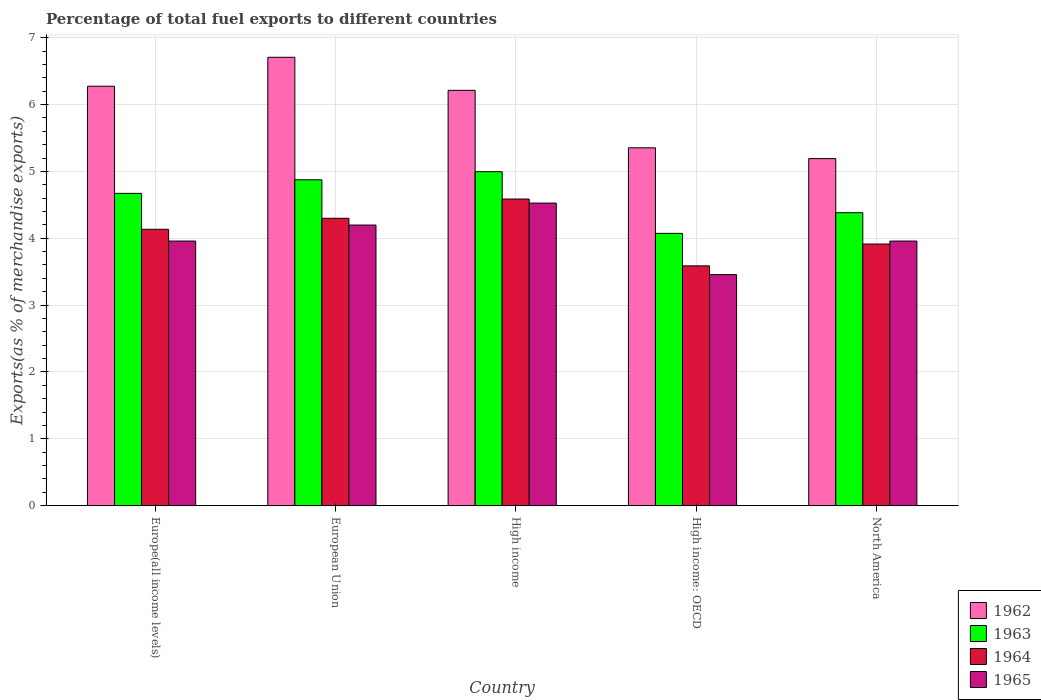Are the number of bars per tick equal to the number of legend labels?
Give a very brief answer. Yes. How many bars are there on the 2nd tick from the right?
Your response must be concise. 4. What is the label of the 1st group of bars from the left?
Your response must be concise. Europe(all income levels). What is the percentage of exports to different countries in 1962 in European Union?
Offer a terse response. 6.71. Across all countries, what is the maximum percentage of exports to different countries in 1964?
Give a very brief answer. 4.59. Across all countries, what is the minimum percentage of exports to different countries in 1965?
Offer a very short reply. 3.46. In which country was the percentage of exports to different countries in 1962 maximum?
Give a very brief answer. European Union. In which country was the percentage of exports to different countries in 1963 minimum?
Give a very brief answer. High income: OECD. What is the total percentage of exports to different countries in 1964 in the graph?
Provide a succinct answer. 20.52. What is the difference between the percentage of exports to different countries in 1963 in European Union and that in High income: OECD?
Ensure brevity in your answer.  0.8. What is the difference between the percentage of exports to different countries in 1964 in North America and the percentage of exports to different countries in 1963 in High income: OECD?
Offer a terse response. -0.16. What is the average percentage of exports to different countries in 1963 per country?
Ensure brevity in your answer.  4.6. What is the difference between the percentage of exports to different countries of/in 1963 and percentage of exports to different countries of/in 1962 in High income: OECD?
Make the answer very short. -1.28. What is the ratio of the percentage of exports to different countries in 1963 in Europe(all income levels) to that in North America?
Your response must be concise. 1.07. Is the percentage of exports to different countries in 1965 in European Union less than that in High income: OECD?
Keep it short and to the point. No. Is the difference between the percentage of exports to different countries in 1963 in European Union and High income greater than the difference between the percentage of exports to different countries in 1962 in European Union and High income?
Make the answer very short. No. What is the difference between the highest and the second highest percentage of exports to different countries in 1963?
Your answer should be very brief. -0.32. What is the difference between the highest and the lowest percentage of exports to different countries in 1964?
Provide a short and direct response. 1. In how many countries, is the percentage of exports to different countries in 1962 greater than the average percentage of exports to different countries in 1962 taken over all countries?
Give a very brief answer. 3. What does the 4th bar from the left in Europe(all income levels) represents?
Offer a very short reply. 1965. How many bars are there?
Your answer should be compact. 20. What is the difference between two consecutive major ticks on the Y-axis?
Your answer should be compact. 1. Are the values on the major ticks of Y-axis written in scientific E-notation?
Provide a succinct answer. No. Does the graph contain grids?
Give a very brief answer. Yes. How many legend labels are there?
Give a very brief answer. 4. How are the legend labels stacked?
Make the answer very short. Vertical. What is the title of the graph?
Offer a very short reply. Percentage of total fuel exports to different countries. What is the label or title of the Y-axis?
Offer a terse response. Exports(as % of merchandise exports). What is the Exports(as % of merchandise exports) of 1962 in Europe(all income levels)?
Your answer should be compact. 6.27. What is the Exports(as % of merchandise exports) of 1963 in Europe(all income levels)?
Keep it short and to the point. 4.67. What is the Exports(as % of merchandise exports) in 1964 in Europe(all income levels)?
Keep it short and to the point. 4.13. What is the Exports(as % of merchandise exports) in 1965 in Europe(all income levels)?
Provide a short and direct response. 3.96. What is the Exports(as % of merchandise exports) of 1962 in European Union?
Make the answer very short. 6.71. What is the Exports(as % of merchandise exports) in 1963 in European Union?
Provide a short and direct response. 4.87. What is the Exports(as % of merchandise exports) in 1964 in European Union?
Provide a succinct answer. 4.3. What is the Exports(as % of merchandise exports) of 1965 in European Union?
Provide a short and direct response. 4.2. What is the Exports(as % of merchandise exports) of 1962 in High income?
Your answer should be very brief. 6.21. What is the Exports(as % of merchandise exports) of 1963 in High income?
Your answer should be compact. 5. What is the Exports(as % of merchandise exports) in 1964 in High income?
Give a very brief answer. 4.59. What is the Exports(as % of merchandise exports) of 1965 in High income?
Provide a succinct answer. 4.53. What is the Exports(as % of merchandise exports) in 1962 in High income: OECD?
Provide a short and direct response. 5.35. What is the Exports(as % of merchandise exports) of 1963 in High income: OECD?
Offer a terse response. 4.07. What is the Exports(as % of merchandise exports) of 1964 in High income: OECD?
Your answer should be very brief. 3.59. What is the Exports(as % of merchandise exports) of 1965 in High income: OECD?
Offer a terse response. 3.46. What is the Exports(as % of merchandise exports) of 1962 in North America?
Offer a terse response. 5.19. What is the Exports(as % of merchandise exports) of 1963 in North America?
Give a very brief answer. 4.38. What is the Exports(as % of merchandise exports) in 1964 in North America?
Give a very brief answer. 3.91. What is the Exports(as % of merchandise exports) in 1965 in North America?
Give a very brief answer. 3.96. Across all countries, what is the maximum Exports(as % of merchandise exports) in 1962?
Your answer should be compact. 6.71. Across all countries, what is the maximum Exports(as % of merchandise exports) of 1963?
Keep it short and to the point. 5. Across all countries, what is the maximum Exports(as % of merchandise exports) in 1964?
Ensure brevity in your answer.  4.59. Across all countries, what is the maximum Exports(as % of merchandise exports) of 1965?
Your response must be concise. 4.53. Across all countries, what is the minimum Exports(as % of merchandise exports) in 1962?
Offer a very short reply. 5.19. Across all countries, what is the minimum Exports(as % of merchandise exports) of 1963?
Make the answer very short. 4.07. Across all countries, what is the minimum Exports(as % of merchandise exports) of 1964?
Offer a terse response. 3.59. Across all countries, what is the minimum Exports(as % of merchandise exports) in 1965?
Make the answer very short. 3.46. What is the total Exports(as % of merchandise exports) in 1962 in the graph?
Keep it short and to the point. 29.73. What is the total Exports(as % of merchandise exports) in 1963 in the graph?
Your answer should be compact. 23. What is the total Exports(as % of merchandise exports) in 1964 in the graph?
Give a very brief answer. 20.52. What is the total Exports(as % of merchandise exports) of 1965 in the graph?
Provide a short and direct response. 20.09. What is the difference between the Exports(as % of merchandise exports) in 1962 in Europe(all income levels) and that in European Union?
Provide a short and direct response. -0.43. What is the difference between the Exports(as % of merchandise exports) in 1963 in Europe(all income levels) and that in European Union?
Make the answer very short. -0.2. What is the difference between the Exports(as % of merchandise exports) in 1964 in Europe(all income levels) and that in European Union?
Ensure brevity in your answer.  -0.16. What is the difference between the Exports(as % of merchandise exports) of 1965 in Europe(all income levels) and that in European Union?
Provide a short and direct response. -0.24. What is the difference between the Exports(as % of merchandise exports) of 1962 in Europe(all income levels) and that in High income?
Provide a succinct answer. 0.06. What is the difference between the Exports(as % of merchandise exports) in 1963 in Europe(all income levels) and that in High income?
Make the answer very short. -0.32. What is the difference between the Exports(as % of merchandise exports) of 1964 in Europe(all income levels) and that in High income?
Your response must be concise. -0.45. What is the difference between the Exports(as % of merchandise exports) of 1965 in Europe(all income levels) and that in High income?
Offer a very short reply. -0.57. What is the difference between the Exports(as % of merchandise exports) of 1962 in Europe(all income levels) and that in High income: OECD?
Your answer should be very brief. 0.92. What is the difference between the Exports(as % of merchandise exports) in 1963 in Europe(all income levels) and that in High income: OECD?
Keep it short and to the point. 0.6. What is the difference between the Exports(as % of merchandise exports) in 1964 in Europe(all income levels) and that in High income: OECD?
Provide a succinct answer. 0.55. What is the difference between the Exports(as % of merchandise exports) of 1965 in Europe(all income levels) and that in High income: OECD?
Give a very brief answer. 0.5. What is the difference between the Exports(as % of merchandise exports) of 1962 in Europe(all income levels) and that in North America?
Your answer should be very brief. 1.08. What is the difference between the Exports(as % of merchandise exports) in 1963 in Europe(all income levels) and that in North America?
Provide a short and direct response. 0.29. What is the difference between the Exports(as % of merchandise exports) of 1964 in Europe(all income levels) and that in North America?
Give a very brief answer. 0.22. What is the difference between the Exports(as % of merchandise exports) in 1962 in European Union and that in High income?
Your response must be concise. 0.49. What is the difference between the Exports(as % of merchandise exports) in 1963 in European Union and that in High income?
Offer a very short reply. -0.12. What is the difference between the Exports(as % of merchandise exports) of 1964 in European Union and that in High income?
Give a very brief answer. -0.29. What is the difference between the Exports(as % of merchandise exports) of 1965 in European Union and that in High income?
Offer a very short reply. -0.33. What is the difference between the Exports(as % of merchandise exports) of 1962 in European Union and that in High income: OECD?
Offer a very short reply. 1.35. What is the difference between the Exports(as % of merchandise exports) in 1963 in European Union and that in High income: OECD?
Provide a succinct answer. 0.8. What is the difference between the Exports(as % of merchandise exports) of 1964 in European Union and that in High income: OECD?
Your answer should be compact. 0.71. What is the difference between the Exports(as % of merchandise exports) of 1965 in European Union and that in High income: OECD?
Offer a terse response. 0.74. What is the difference between the Exports(as % of merchandise exports) of 1962 in European Union and that in North America?
Your response must be concise. 1.52. What is the difference between the Exports(as % of merchandise exports) in 1963 in European Union and that in North America?
Provide a succinct answer. 0.49. What is the difference between the Exports(as % of merchandise exports) in 1964 in European Union and that in North America?
Provide a succinct answer. 0.39. What is the difference between the Exports(as % of merchandise exports) in 1965 in European Union and that in North America?
Your response must be concise. 0.24. What is the difference between the Exports(as % of merchandise exports) in 1962 in High income and that in High income: OECD?
Your response must be concise. 0.86. What is the difference between the Exports(as % of merchandise exports) in 1963 in High income and that in High income: OECD?
Ensure brevity in your answer.  0.92. What is the difference between the Exports(as % of merchandise exports) in 1964 in High income and that in High income: OECD?
Give a very brief answer. 1. What is the difference between the Exports(as % of merchandise exports) of 1965 in High income and that in High income: OECD?
Ensure brevity in your answer.  1.07. What is the difference between the Exports(as % of merchandise exports) in 1963 in High income and that in North America?
Keep it short and to the point. 0.61. What is the difference between the Exports(as % of merchandise exports) in 1964 in High income and that in North America?
Your answer should be very brief. 0.67. What is the difference between the Exports(as % of merchandise exports) in 1965 in High income and that in North America?
Offer a terse response. 0.57. What is the difference between the Exports(as % of merchandise exports) of 1962 in High income: OECD and that in North America?
Offer a terse response. 0.16. What is the difference between the Exports(as % of merchandise exports) of 1963 in High income: OECD and that in North America?
Keep it short and to the point. -0.31. What is the difference between the Exports(as % of merchandise exports) of 1964 in High income: OECD and that in North America?
Your response must be concise. -0.33. What is the difference between the Exports(as % of merchandise exports) in 1965 in High income: OECD and that in North America?
Your response must be concise. -0.5. What is the difference between the Exports(as % of merchandise exports) of 1962 in Europe(all income levels) and the Exports(as % of merchandise exports) of 1963 in European Union?
Make the answer very short. 1.4. What is the difference between the Exports(as % of merchandise exports) in 1962 in Europe(all income levels) and the Exports(as % of merchandise exports) in 1964 in European Union?
Your answer should be very brief. 1.97. What is the difference between the Exports(as % of merchandise exports) in 1962 in Europe(all income levels) and the Exports(as % of merchandise exports) in 1965 in European Union?
Your answer should be very brief. 2.08. What is the difference between the Exports(as % of merchandise exports) of 1963 in Europe(all income levels) and the Exports(as % of merchandise exports) of 1964 in European Union?
Provide a succinct answer. 0.37. What is the difference between the Exports(as % of merchandise exports) of 1963 in Europe(all income levels) and the Exports(as % of merchandise exports) of 1965 in European Union?
Provide a succinct answer. 0.47. What is the difference between the Exports(as % of merchandise exports) in 1964 in Europe(all income levels) and the Exports(as % of merchandise exports) in 1965 in European Union?
Offer a very short reply. -0.06. What is the difference between the Exports(as % of merchandise exports) in 1962 in Europe(all income levels) and the Exports(as % of merchandise exports) in 1963 in High income?
Make the answer very short. 1.28. What is the difference between the Exports(as % of merchandise exports) in 1962 in Europe(all income levels) and the Exports(as % of merchandise exports) in 1964 in High income?
Keep it short and to the point. 1.69. What is the difference between the Exports(as % of merchandise exports) in 1962 in Europe(all income levels) and the Exports(as % of merchandise exports) in 1965 in High income?
Your answer should be very brief. 1.75. What is the difference between the Exports(as % of merchandise exports) in 1963 in Europe(all income levels) and the Exports(as % of merchandise exports) in 1964 in High income?
Offer a terse response. 0.08. What is the difference between the Exports(as % of merchandise exports) in 1963 in Europe(all income levels) and the Exports(as % of merchandise exports) in 1965 in High income?
Your answer should be very brief. 0.15. What is the difference between the Exports(as % of merchandise exports) in 1964 in Europe(all income levels) and the Exports(as % of merchandise exports) in 1965 in High income?
Your response must be concise. -0.39. What is the difference between the Exports(as % of merchandise exports) in 1962 in Europe(all income levels) and the Exports(as % of merchandise exports) in 1963 in High income: OECD?
Provide a succinct answer. 2.2. What is the difference between the Exports(as % of merchandise exports) of 1962 in Europe(all income levels) and the Exports(as % of merchandise exports) of 1964 in High income: OECD?
Your answer should be very brief. 2.69. What is the difference between the Exports(as % of merchandise exports) in 1962 in Europe(all income levels) and the Exports(as % of merchandise exports) in 1965 in High income: OECD?
Keep it short and to the point. 2.82. What is the difference between the Exports(as % of merchandise exports) in 1963 in Europe(all income levels) and the Exports(as % of merchandise exports) in 1964 in High income: OECD?
Your response must be concise. 1.08. What is the difference between the Exports(as % of merchandise exports) in 1963 in Europe(all income levels) and the Exports(as % of merchandise exports) in 1965 in High income: OECD?
Your response must be concise. 1.22. What is the difference between the Exports(as % of merchandise exports) in 1964 in Europe(all income levels) and the Exports(as % of merchandise exports) in 1965 in High income: OECD?
Give a very brief answer. 0.68. What is the difference between the Exports(as % of merchandise exports) in 1962 in Europe(all income levels) and the Exports(as % of merchandise exports) in 1963 in North America?
Your answer should be very brief. 1.89. What is the difference between the Exports(as % of merchandise exports) in 1962 in Europe(all income levels) and the Exports(as % of merchandise exports) in 1964 in North America?
Ensure brevity in your answer.  2.36. What is the difference between the Exports(as % of merchandise exports) in 1962 in Europe(all income levels) and the Exports(as % of merchandise exports) in 1965 in North America?
Your answer should be very brief. 2.32. What is the difference between the Exports(as % of merchandise exports) of 1963 in Europe(all income levels) and the Exports(as % of merchandise exports) of 1964 in North America?
Your response must be concise. 0.76. What is the difference between the Exports(as % of merchandise exports) of 1963 in Europe(all income levels) and the Exports(as % of merchandise exports) of 1965 in North America?
Offer a very short reply. 0.71. What is the difference between the Exports(as % of merchandise exports) in 1964 in Europe(all income levels) and the Exports(as % of merchandise exports) in 1965 in North America?
Keep it short and to the point. 0.18. What is the difference between the Exports(as % of merchandise exports) of 1962 in European Union and the Exports(as % of merchandise exports) of 1963 in High income?
Offer a terse response. 1.71. What is the difference between the Exports(as % of merchandise exports) in 1962 in European Union and the Exports(as % of merchandise exports) in 1964 in High income?
Provide a succinct answer. 2.12. What is the difference between the Exports(as % of merchandise exports) in 1962 in European Union and the Exports(as % of merchandise exports) in 1965 in High income?
Your response must be concise. 2.18. What is the difference between the Exports(as % of merchandise exports) in 1963 in European Union and the Exports(as % of merchandise exports) in 1964 in High income?
Provide a short and direct response. 0.29. What is the difference between the Exports(as % of merchandise exports) of 1963 in European Union and the Exports(as % of merchandise exports) of 1965 in High income?
Your answer should be very brief. 0.35. What is the difference between the Exports(as % of merchandise exports) of 1964 in European Union and the Exports(as % of merchandise exports) of 1965 in High income?
Provide a short and direct response. -0.23. What is the difference between the Exports(as % of merchandise exports) of 1962 in European Union and the Exports(as % of merchandise exports) of 1963 in High income: OECD?
Keep it short and to the point. 2.63. What is the difference between the Exports(as % of merchandise exports) of 1962 in European Union and the Exports(as % of merchandise exports) of 1964 in High income: OECD?
Your answer should be compact. 3.12. What is the difference between the Exports(as % of merchandise exports) of 1962 in European Union and the Exports(as % of merchandise exports) of 1965 in High income: OECD?
Offer a very short reply. 3.25. What is the difference between the Exports(as % of merchandise exports) of 1963 in European Union and the Exports(as % of merchandise exports) of 1964 in High income: OECD?
Provide a short and direct response. 1.29. What is the difference between the Exports(as % of merchandise exports) of 1963 in European Union and the Exports(as % of merchandise exports) of 1965 in High income: OECD?
Offer a terse response. 1.42. What is the difference between the Exports(as % of merchandise exports) of 1964 in European Union and the Exports(as % of merchandise exports) of 1965 in High income: OECD?
Your answer should be compact. 0.84. What is the difference between the Exports(as % of merchandise exports) of 1962 in European Union and the Exports(as % of merchandise exports) of 1963 in North America?
Your answer should be compact. 2.32. What is the difference between the Exports(as % of merchandise exports) in 1962 in European Union and the Exports(as % of merchandise exports) in 1964 in North America?
Your answer should be compact. 2.79. What is the difference between the Exports(as % of merchandise exports) in 1962 in European Union and the Exports(as % of merchandise exports) in 1965 in North America?
Keep it short and to the point. 2.75. What is the difference between the Exports(as % of merchandise exports) of 1963 in European Union and the Exports(as % of merchandise exports) of 1964 in North America?
Your response must be concise. 0.96. What is the difference between the Exports(as % of merchandise exports) of 1963 in European Union and the Exports(as % of merchandise exports) of 1965 in North America?
Your answer should be compact. 0.92. What is the difference between the Exports(as % of merchandise exports) of 1964 in European Union and the Exports(as % of merchandise exports) of 1965 in North America?
Provide a succinct answer. 0.34. What is the difference between the Exports(as % of merchandise exports) in 1962 in High income and the Exports(as % of merchandise exports) in 1963 in High income: OECD?
Your answer should be very brief. 2.14. What is the difference between the Exports(as % of merchandise exports) of 1962 in High income and the Exports(as % of merchandise exports) of 1964 in High income: OECD?
Your answer should be very brief. 2.62. What is the difference between the Exports(as % of merchandise exports) in 1962 in High income and the Exports(as % of merchandise exports) in 1965 in High income: OECD?
Offer a terse response. 2.76. What is the difference between the Exports(as % of merchandise exports) of 1963 in High income and the Exports(as % of merchandise exports) of 1964 in High income: OECD?
Provide a short and direct response. 1.41. What is the difference between the Exports(as % of merchandise exports) of 1963 in High income and the Exports(as % of merchandise exports) of 1965 in High income: OECD?
Your response must be concise. 1.54. What is the difference between the Exports(as % of merchandise exports) of 1964 in High income and the Exports(as % of merchandise exports) of 1965 in High income: OECD?
Your response must be concise. 1.13. What is the difference between the Exports(as % of merchandise exports) of 1962 in High income and the Exports(as % of merchandise exports) of 1963 in North America?
Keep it short and to the point. 1.83. What is the difference between the Exports(as % of merchandise exports) in 1962 in High income and the Exports(as % of merchandise exports) in 1964 in North America?
Give a very brief answer. 2.3. What is the difference between the Exports(as % of merchandise exports) in 1962 in High income and the Exports(as % of merchandise exports) in 1965 in North America?
Your response must be concise. 2.25. What is the difference between the Exports(as % of merchandise exports) of 1963 in High income and the Exports(as % of merchandise exports) of 1964 in North America?
Your response must be concise. 1.08. What is the difference between the Exports(as % of merchandise exports) in 1963 in High income and the Exports(as % of merchandise exports) in 1965 in North America?
Your answer should be compact. 1.04. What is the difference between the Exports(as % of merchandise exports) in 1964 in High income and the Exports(as % of merchandise exports) in 1965 in North America?
Ensure brevity in your answer.  0.63. What is the difference between the Exports(as % of merchandise exports) of 1962 in High income: OECD and the Exports(as % of merchandise exports) of 1963 in North America?
Give a very brief answer. 0.97. What is the difference between the Exports(as % of merchandise exports) of 1962 in High income: OECD and the Exports(as % of merchandise exports) of 1964 in North America?
Your response must be concise. 1.44. What is the difference between the Exports(as % of merchandise exports) in 1962 in High income: OECD and the Exports(as % of merchandise exports) in 1965 in North America?
Provide a short and direct response. 1.39. What is the difference between the Exports(as % of merchandise exports) of 1963 in High income: OECD and the Exports(as % of merchandise exports) of 1964 in North America?
Offer a very short reply. 0.16. What is the difference between the Exports(as % of merchandise exports) of 1963 in High income: OECD and the Exports(as % of merchandise exports) of 1965 in North America?
Ensure brevity in your answer.  0.12. What is the difference between the Exports(as % of merchandise exports) of 1964 in High income: OECD and the Exports(as % of merchandise exports) of 1965 in North America?
Ensure brevity in your answer.  -0.37. What is the average Exports(as % of merchandise exports) of 1962 per country?
Offer a very short reply. 5.95. What is the average Exports(as % of merchandise exports) in 1963 per country?
Give a very brief answer. 4.6. What is the average Exports(as % of merchandise exports) of 1964 per country?
Make the answer very short. 4.1. What is the average Exports(as % of merchandise exports) in 1965 per country?
Offer a terse response. 4.02. What is the difference between the Exports(as % of merchandise exports) of 1962 and Exports(as % of merchandise exports) of 1963 in Europe(all income levels)?
Keep it short and to the point. 1.6. What is the difference between the Exports(as % of merchandise exports) in 1962 and Exports(as % of merchandise exports) in 1964 in Europe(all income levels)?
Ensure brevity in your answer.  2.14. What is the difference between the Exports(as % of merchandise exports) in 1962 and Exports(as % of merchandise exports) in 1965 in Europe(all income levels)?
Make the answer very short. 2.32. What is the difference between the Exports(as % of merchandise exports) of 1963 and Exports(as % of merchandise exports) of 1964 in Europe(all income levels)?
Ensure brevity in your answer.  0.54. What is the difference between the Exports(as % of merchandise exports) of 1963 and Exports(as % of merchandise exports) of 1965 in Europe(all income levels)?
Offer a terse response. 0.71. What is the difference between the Exports(as % of merchandise exports) in 1964 and Exports(as % of merchandise exports) in 1965 in Europe(all income levels)?
Provide a short and direct response. 0.18. What is the difference between the Exports(as % of merchandise exports) of 1962 and Exports(as % of merchandise exports) of 1963 in European Union?
Offer a very short reply. 1.83. What is the difference between the Exports(as % of merchandise exports) of 1962 and Exports(as % of merchandise exports) of 1964 in European Union?
Offer a very short reply. 2.41. What is the difference between the Exports(as % of merchandise exports) in 1962 and Exports(as % of merchandise exports) in 1965 in European Union?
Provide a short and direct response. 2.51. What is the difference between the Exports(as % of merchandise exports) of 1963 and Exports(as % of merchandise exports) of 1964 in European Union?
Provide a short and direct response. 0.58. What is the difference between the Exports(as % of merchandise exports) in 1963 and Exports(as % of merchandise exports) in 1965 in European Union?
Your answer should be very brief. 0.68. What is the difference between the Exports(as % of merchandise exports) in 1964 and Exports(as % of merchandise exports) in 1965 in European Union?
Offer a terse response. 0.1. What is the difference between the Exports(as % of merchandise exports) in 1962 and Exports(as % of merchandise exports) in 1963 in High income?
Ensure brevity in your answer.  1.22. What is the difference between the Exports(as % of merchandise exports) in 1962 and Exports(as % of merchandise exports) in 1964 in High income?
Your response must be concise. 1.63. What is the difference between the Exports(as % of merchandise exports) in 1962 and Exports(as % of merchandise exports) in 1965 in High income?
Your response must be concise. 1.69. What is the difference between the Exports(as % of merchandise exports) in 1963 and Exports(as % of merchandise exports) in 1964 in High income?
Make the answer very short. 0.41. What is the difference between the Exports(as % of merchandise exports) in 1963 and Exports(as % of merchandise exports) in 1965 in High income?
Provide a short and direct response. 0.47. What is the difference between the Exports(as % of merchandise exports) of 1964 and Exports(as % of merchandise exports) of 1965 in High income?
Your answer should be compact. 0.06. What is the difference between the Exports(as % of merchandise exports) of 1962 and Exports(as % of merchandise exports) of 1963 in High income: OECD?
Ensure brevity in your answer.  1.28. What is the difference between the Exports(as % of merchandise exports) of 1962 and Exports(as % of merchandise exports) of 1964 in High income: OECD?
Provide a succinct answer. 1.77. What is the difference between the Exports(as % of merchandise exports) of 1962 and Exports(as % of merchandise exports) of 1965 in High income: OECD?
Provide a short and direct response. 1.9. What is the difference between the Exports(as % of merchandise exports) of 1963 and Exports(as % of merchandise exports) of 1964 in High income: OECD?
Offer a terse response. 0.49. What is the difference between the Exports(as % of merchandise exports) in 1963 and Exports(as % of merchandise exports) in 1965 in High income: OECD?
Your answer should be very brief. 0.62. What is the difference between the Exports(as % of merchandise exports) of 1964 and Exports(as % of merchandise exports) of 1965 in High income: OECD?
Your answer should be very brief. 0.13. What is the difference between the Exports(as % of merchandise exports) in 1962 and Exports(as % of merchandise exports) in 1963 in North America?
Provide a succinct answer. 0.81. What is the difference between the Exports(as % of merchandise exports) in 1962 and Exports(as % of merchandise exports) in 1964 in North America?
Ensure brevity in your answer.  1.28. What is the difference between the Exports(as % of merchandise exports) in 1962 and Exports(as % of merchandise exports) in 1965 in North America?
Your answer should be very brief. 1.23. What is the difference between the Exports(as % of merchandise exports) of 1963 and Exports(as % of merchandise exports) of 1964 in North America?
Give a very brief answer. 0.47. What is the difference between the Exports(as % of merchandise exports) in 1963 and Exports(as % of merchandise exports) in 1965 in North America?
Keep it short and to the point. 0.42. What is the difference between the Exports(as % of merchandise exports) of 1964 and Exports(as % of merchandise exports) of 1965 in North America?
Ensure brevity in your answer.  -0.04. What is the ratio of the Exports(as % of merchandise exports) of 1962 in Europe(all income levels) to that in European Union?
Your response must be concise. 0.94. What is the ratio of the Exports(as % of merchandise exports) in 1963 in Europe(all income levels) to that in European Union?
Keep it short and to the point. 0.96. What is the ratio of the Exports(as % of merchandise exports) of 1964 in Europe(all income levels) to that in European Union?
Provide a succinct answer. 0.96. What is the ratio of the Exports(as % of merchandise exports) of 1965 in Europe(all income levels) to that in European Union?
Offer a very short reply. 0.94. What is the ratio of the Exports(as % of merchandise exports) of 1962 in Europe(all income levels) to that in High income?
Make the answer very short. 1.01. What is the ratio of the Exports(as % of merchandise exports) of 1963 in Europe(all income levels) to that in High income?
Offer a very short reply. 0.94. What is the ratio of the Exports(as % of merchandise exports) in 1964 in Europe(all income levels) to that in High income?
Ensure brevity in your answer.  0.9. What is the ratio of the Exports(as % of merchandise exports) in 1965 in Europe(all income levels) to that in High income?
Make the answer very short. 0.87. What is the ratio of the Exports(as % of merchandise exports) in 1962 in Europe(all income levels) to that in High income: OECD?
Give a very brief answer. 1.17. What is the ratio of the Exports(as % of merchandise exports) of 1963 in Europe(all income levels) to that in High income: OECD?
Provide a short and direct response. 1.15. What is the ratio of the Exports(as % of merchandise exports) in 1964 in Europe(all income levels) to that in High income: OECD?
Make the answer very short. 1.15. What is the ratio of the Exports(as % of merchandise exports) in 1965 in Europe(all income levels) to that in High income: OECD?
Your answer should be very brief. 1.15. What is the ratio of the Exports(as % of merchandise exports) in 1962 in Europe(all income levels) to that in North America?
Your response must be concise. 1.21. What is the ratio of the Exports(as % of merchandise exports) of 1963 in Europe(all income levels) to that in North America?
Provide a short and direct response. 1.07. What is the ratio of the Exports(as % of merchandise exports) in 1964 in Europe(all income levels) to that in North America?
Your answer should be very brief. 1.06. What is the ratio of the Exports(as % of merchandise exports) of 1962 in European Union to that in High income?
Provide a short and direct response. 1.08. What is the ratio of the Exports(as % of merchandise exports) of 1963 in European Union to that in High income?
Your answer should be compact. 0.98. What is the ratio of the Exports(as % of merchandise exports) in 1964 in European Union to that in High income?
Your answer should be very brief. 0.94. What is the ratio of the Exports(as % of merchandise exports) in 1965 in European Union to that in High income?
Provide a short and direct response. 0.93. What is the ratio of the Exports(as % of merchandise exports) of 1962 in European Union to that in High income: OECD?
Give a very brief answer. 1.25. What is the ratio of the Exports(as % of merchandise exports) of 1963 in European Union to that in High income: OECD?
Offer a terse response. 1.2. What is the ratio of the Exports(as % of merchandise exports) in 1964 in European Union to that in High income: OECD?
Offer a terse response. 1.2. What is the ratio of the Exports(as % of merchandise exports) of 1965 in European Union to that in High income: OECD?
Keep it short and to the point. 1.21. What is the ratio of the Exports(as % of merchandise exports) of 1962 in European Union to that in North America?
Your answer should be compact. 1.29. What is the ratio of the Exports(as % of merchandise exports) of 1963 in European Union to that in North America?
Keep it short and to the point. 1.11. What is the ratio of the Exports(as % of merchandise exports) in 1964 in European Union to that in North America?
Make the answer very short. 1.1. What is the ratio of the Exports(as % of merchandise exports) in 1965 in European Union to that in North America?
Offer a very short reply. 1.06. What is the ratio of the Exports(as % of merchandise exports) in 1962 in High income to that in High income: OECD?
Keep it short and to the point. 1.16. What is the ratio of the Exports(as % of merchandise exports) of 1963 in High income to that in High income: OECD?
Give a very brief answer. 1.23. What is the ratio of the Exports(as % of merchandise exports) of 1964 in High income to that in High income: OECD?
Provide a short and direct response. 1.28. What is the ratio of the Exports(as % of merchandise exports) of 1965 in High income to that in High income: OECD?
Your answer should be very brief. 1.31. What is the ratio of the Exports(as % of merchandise exports) in 1962 in High income to that in North America?
Ensure brevity in your answer.  1.2. What is the ratio of the Exports(as % of merchandise exports) in 1963 in High income to that in North America?
Your answer should be compact. 1.14. What is the ratio of the Exports(as % of merchandise exports) of 1964 in High income to that in North America?
Keep it short and to the point. 1.17. What is the ratio of the Exports(as % of merchandise exports) in 1965 in High income to that in North America?
Offer a terse response. 1.14. What is the ratio of the Exports(as % of merchandise exports) of 1962 in High income: OECD to that in North America?
Offer a terse response. 1.03. What is the ratio of the Exports(as % of merchandise exports) of 1963 in High income: OECD to that in North America?
Keep it short and to the point. 0.93. What is the ratio of the Exports(as % of merchandise exports) of 1964 in High income: OECD to that in North America?
Ensure brevity in your answer.  0.92. What is the ratio of the Exports(as % of merchandise exports) of 1965 in High income: OECD to that in North America?
Provide a short and direct response. 0.87. What is the difference between the highest and the second highest Exports(as % of merchandise exports) of 1962?
Provide a succinct answer. 0.43. What is the difference between the highest and the second highest Exports(as % of merchandise exports) in 1963?
Your answer should be very brief. 0.12. What is the difference between the highest and the second highest Exports(as % of merchandise exports) in 1964?
Offer a very short reply. 0.29. What is the difference between the highest and the second highest Exports(as % of merchandise exports) in 1965?
Provide a short and direct response. 0.33. What is the difference between the highest and the lowest Exports(as % of merchandise exports) of 1962?
Keep it short and to the point. 1.52. What is the difference between the highest and the lowest Exports(as % of merchandise exports) of 1963?
Your response must be concise. 0.92. What is the difference between the highest and the lowest Exports(as % of merchandise exports) in 1965?
Provide a short and direct response. 1.07. 